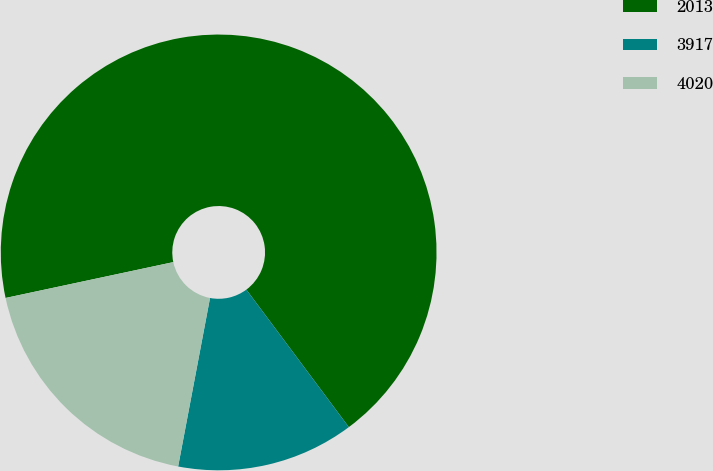Convert chart. <chart><loc_0><loc_0><loc_500><loc_500><pie_chart><fcel>2013<fcel>3917<fcel>4020<nl><fcel>68.15%<fcel>13.17%<fcel>18.67%<nl></chart> 